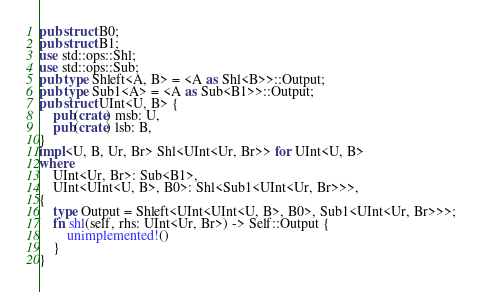Convert code to text. <code><loc_0><loc_0><loc_500><loc_500><_Rust_>pub struct B0;
pub struct B1;
use std::ops::Shl;
use std::ops::Sub;
pub type Shleft<A, B> = <A as Shl<B>>::Output;
pub type Sub1<A> = <A as Sub<B1>>::Output;
pub struct UInt<U, B> {
    pub(crate) msb: U,
    pub(crate) lsb: B,
}
impl<U, B, Ur, Br> Shl<UInt<Ur, Br>> for UInt<U, B>
where
    UInt<Ur, Br>: Sub<B1>,
    UInt<UInt<U, B>, B0>: Shl<Sub1<UInt<Ur, Br>>>,
{
    type Output = Shleft<UInt<UInt<U, B>, B0>, Sub1<UInt<Ur, Br>>>;
    fn shl(self, rhs: UInt<Ur, Br>) -> Self::Output {
        unimplemented!()
    }
}
</code> 